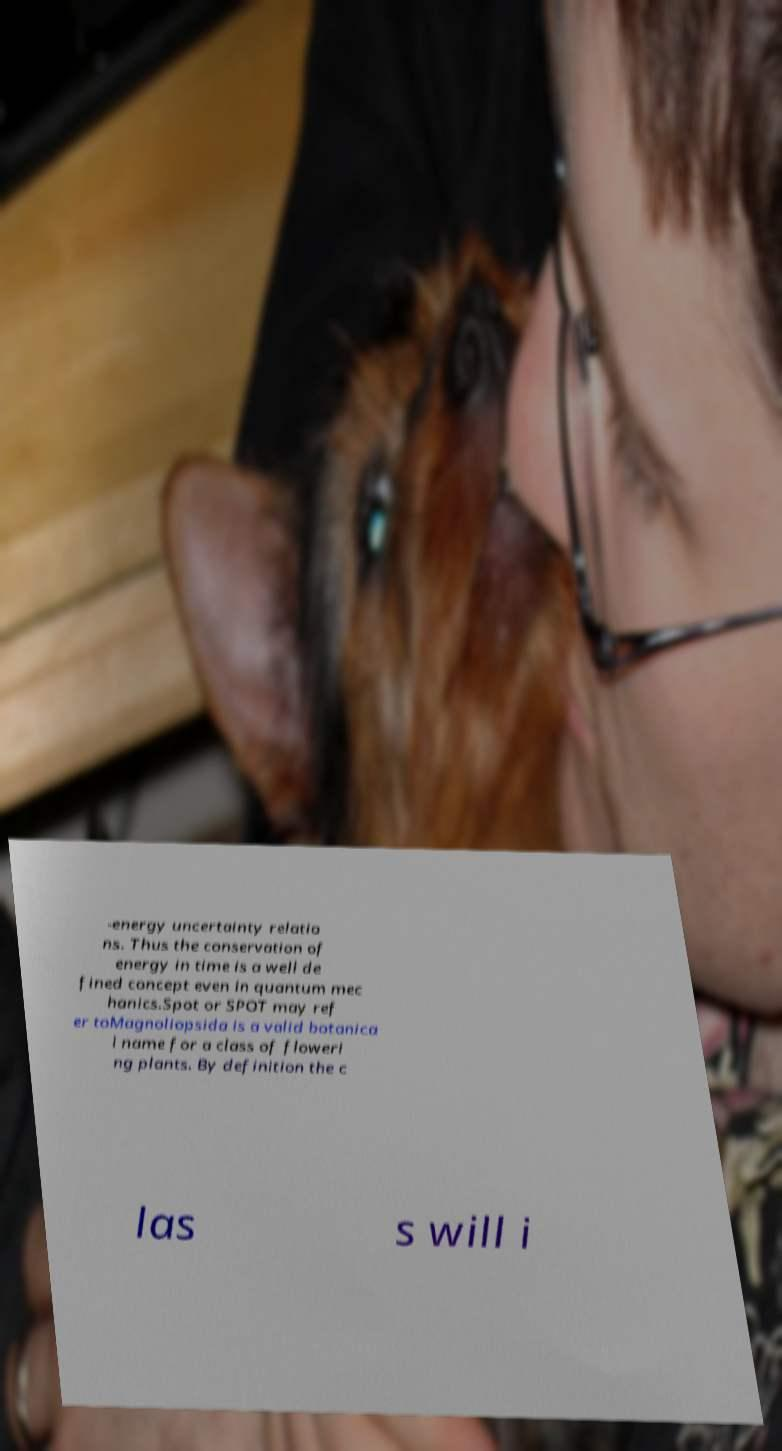What messages or text are displayed in this image? I need them in a readable, typed format. -energy uncertainty relatio ns. Thus the conservation of energy in time is a well de fined concept even in quantum mec hanics.Spot or SPOT may ref er toMagnoliopsida is a valid botanica l name for a class of floweri ng plants. By definition the c las s will i 